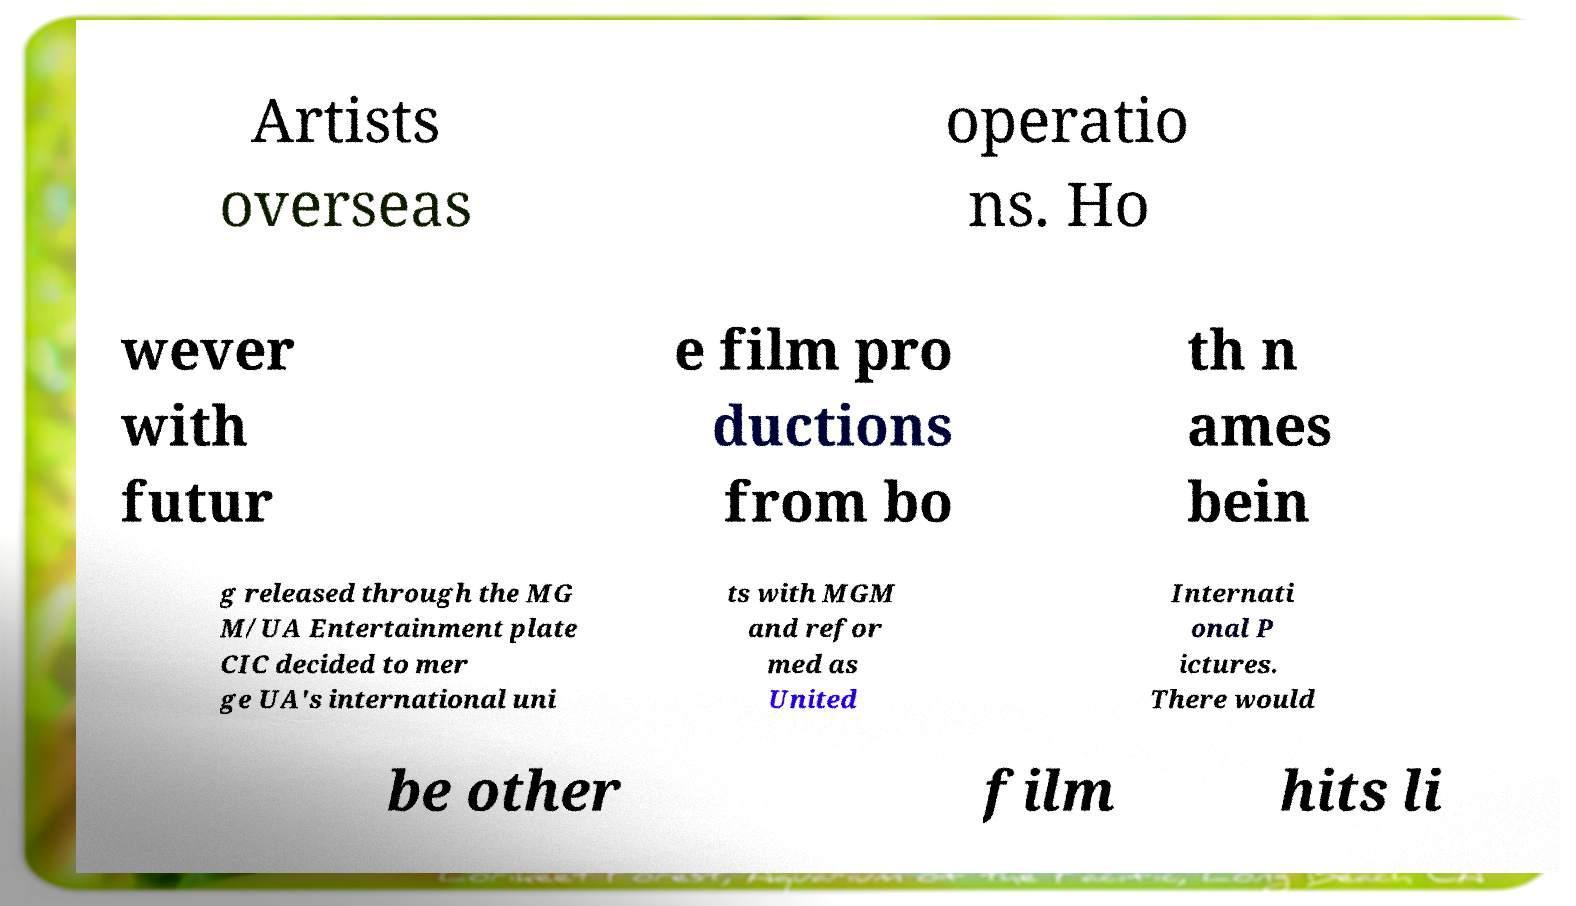Could you extract and type out the text from this image? Artists overseas operatio ns. Ho wever with futur e film pro ductions from bo th n ames bein g released through the MG M/UA Entertainment plate CIC decided to mer ge UA's international uni ts with MGM and refor med as United Internati onal P ictures. There would be other film hits li 